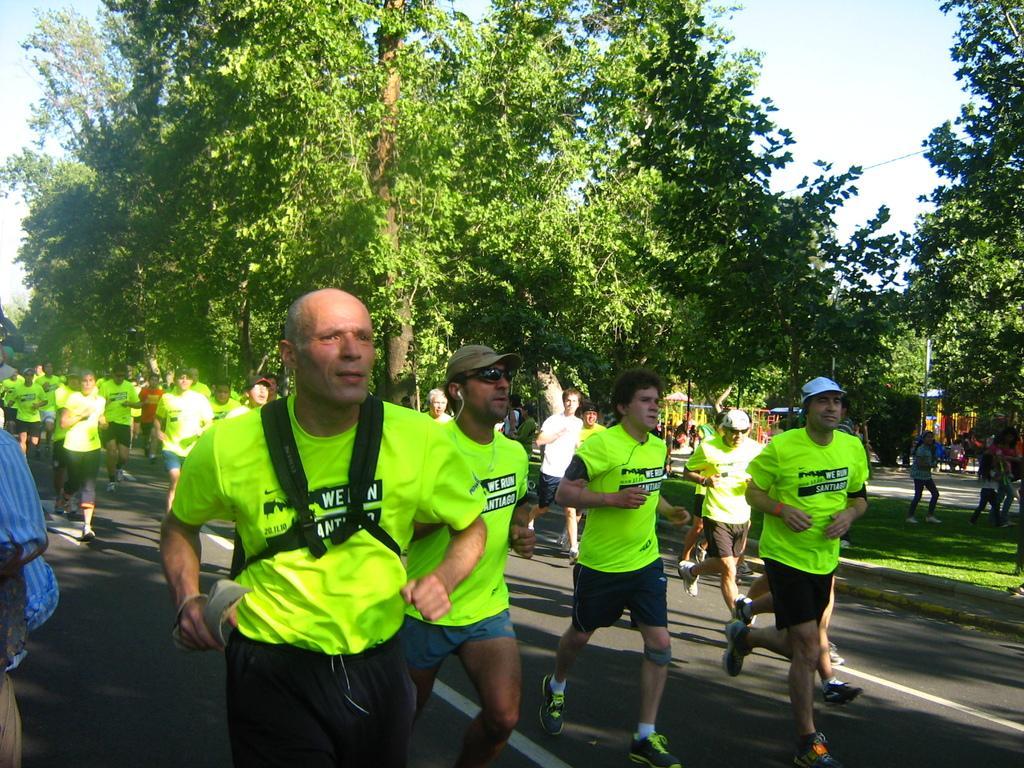In one or two sentences, can you explain what this image depicts? In the background we can see sky and it seems like a sunny day. We can see trees. We can see people wearing t-shirts and running on the road. 